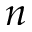Convert formula to latex. <formula><loc_0><loc_0><loc_500><loc_500>n</formula> 